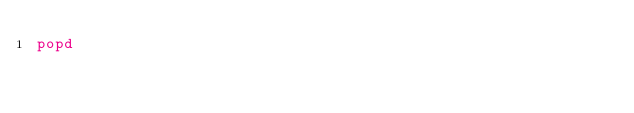<code> <loc_0><loc_0><loc_500><loc_500><_Bash_>popd
</code> 